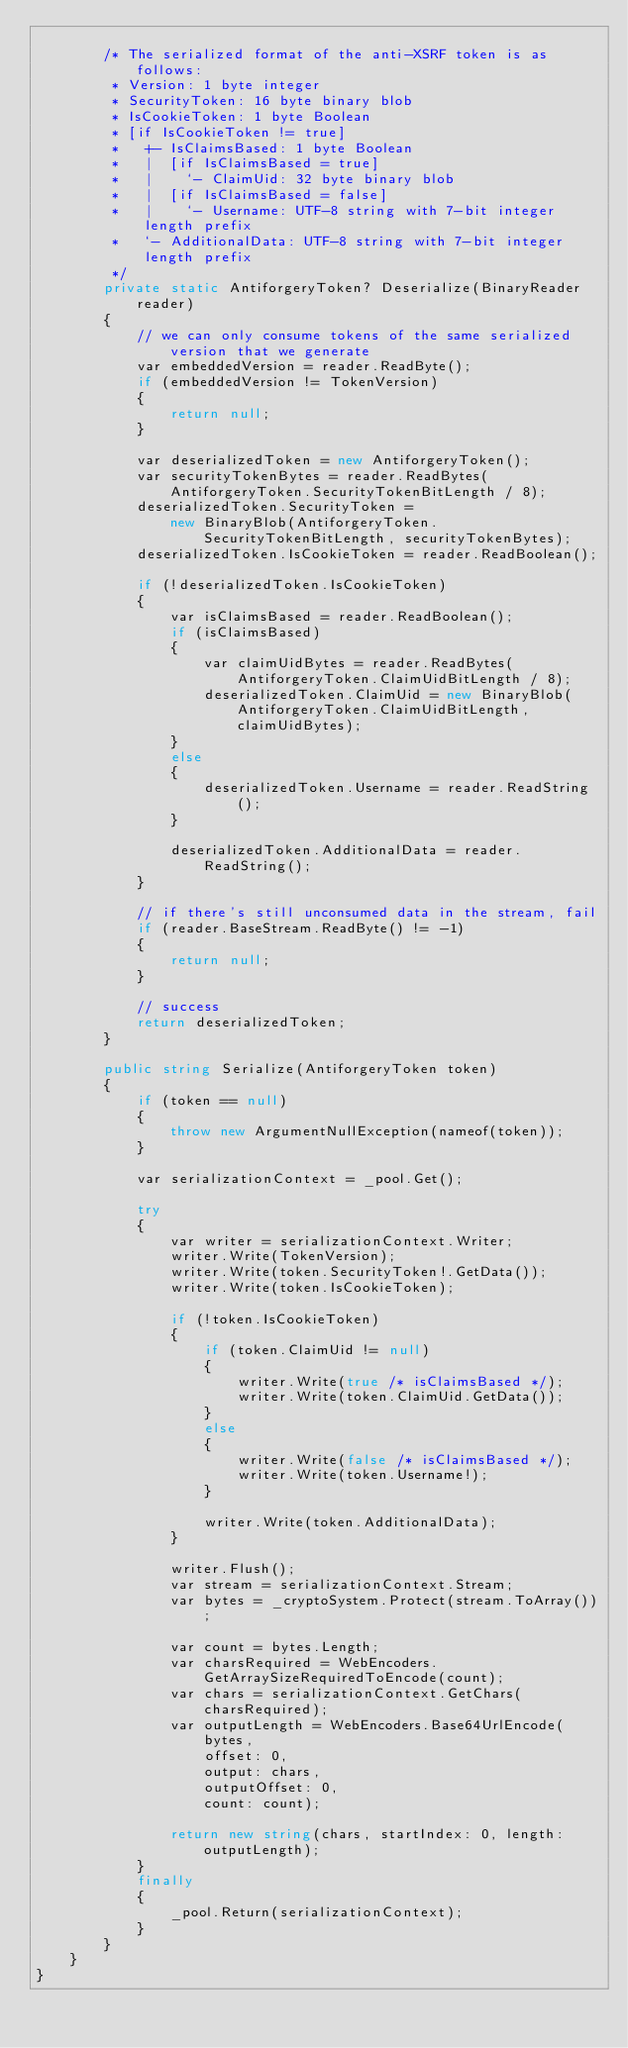Convert code to text. <code><loc_0><loc_0><loc_500><loc_500><_C#_>
        /* The serialized format of the anti-XSRF token is as follows:
         * Version: 1 byte integer
         * SecurityToken: 16 byte binary blob
         * IsCookieToken: 1 byte Boolean
         * [if IsCookieToken != true]
         *   +- IsClaimsBased: 1 byte Boolean
         *   |  [if IsClaimsBased = true]
         *   |    `- ClaimUid: 32 byte binary blob
         *   |  [if IsClaimsBased = false]
         *   |    `- Username: UTF-8 string with 7-bit integer length prefix
         *   `- AdditionalData: UTF-8 string with 7-bit integer length prefix
         */
        private static AntiforgeryToken? Deserialize(BinaryReader reader)
        {
            // we can only consume tokens of the same serialized version that we generate
            var embeddedVersion = reader.ReadByte();
            if (embeddedVersion != TokenVersion)
            {
                return null;
            }

            var deserializedToken = new AntiforgeryToken();
            var securityTokenBytes = reader.ReadBytes(AntiforgeryToken.SecurityTokenBitLength / 8);
            deserializedToken.SecurityToken =
                new BinaryBlob(AntiforgeryToken.SecurityTokenBitLength, securityTokenBytes);
            deserializedToken.IsCookieToken = reader.ReadBoolean();

            if (!deserializedToken.IsCookieToken)
            {
                var isClaimsBased = reader.ReadBoolean();
                if (isClaimsBased)
                {
                    var claimUidBytes = reader.ReadBytes(AntiforgeryToken.ClaimUidBitLength / 8);
                    deserializedToken.ClaimUid = new BinaryBlob(AntiforgeryToken.ClaimUidBitLength, claimUidBytes);
                }
                else
                {
                    deserializedToken.Username = reader.ReadString();
                }

                deserializedToken.AdditionalData = reader.ReadString();
            }

            // if there's still unconsumed data in the stream, fail
            if (reader.BaseStream.ReadByte() != -1)
            {
                return null;
            }

            // success
            return deserializedToken;
        }

        public string Serialize(AntiforgeryToken token)
        {
            if (token == null)
            {
                throw new ArgumentNullException(nameof(token));
            }

            var serializationContext = _pool.Get();

            try
            {
                var writer = serializationContext.Writer;
                writer.Write(TokenVersion);
                writer.Write(token.SecurityToken!.GetData());
                writer.Write(token.IsCookieToken);

                if (!token.IsCookieToken)
                {
                    if (token.ClaimUid != null)
                    {
                        writer.Write(true /* isClaimsBased */);
                        writer.Write(token.ClaimUid.GetData());
                    }
                    else
                    {
                        writer.Write(false /* isClaimsBased */);
                        writer.Write(token.Username!);
                    }

                    writer.Write(token.AdditionalData);
                }

                writer.Flush();
                var stream = serializationContext.Stream;
                var bytes = _cryptoSystem.Protect(stream.ToArray());

                var count = bytes.Length;
                var charsRequired = WebEncoders.GetArraySizeRequiredToEncode(count);
                var chars = serializationContext.GetChars(charsRequired);
                var outputLength = WebEncoders.Base64UrlEncode(
                    bytes,
                    offset: 0,
                    output: chars,
                    outputOffset: 0,
                    count: count);

                return new string(chars, startIndex: 0, length: outputLength);
            }
            finally
            {
                _pool.Return(serializationContext);
            }
        }
    }
}
</code> 